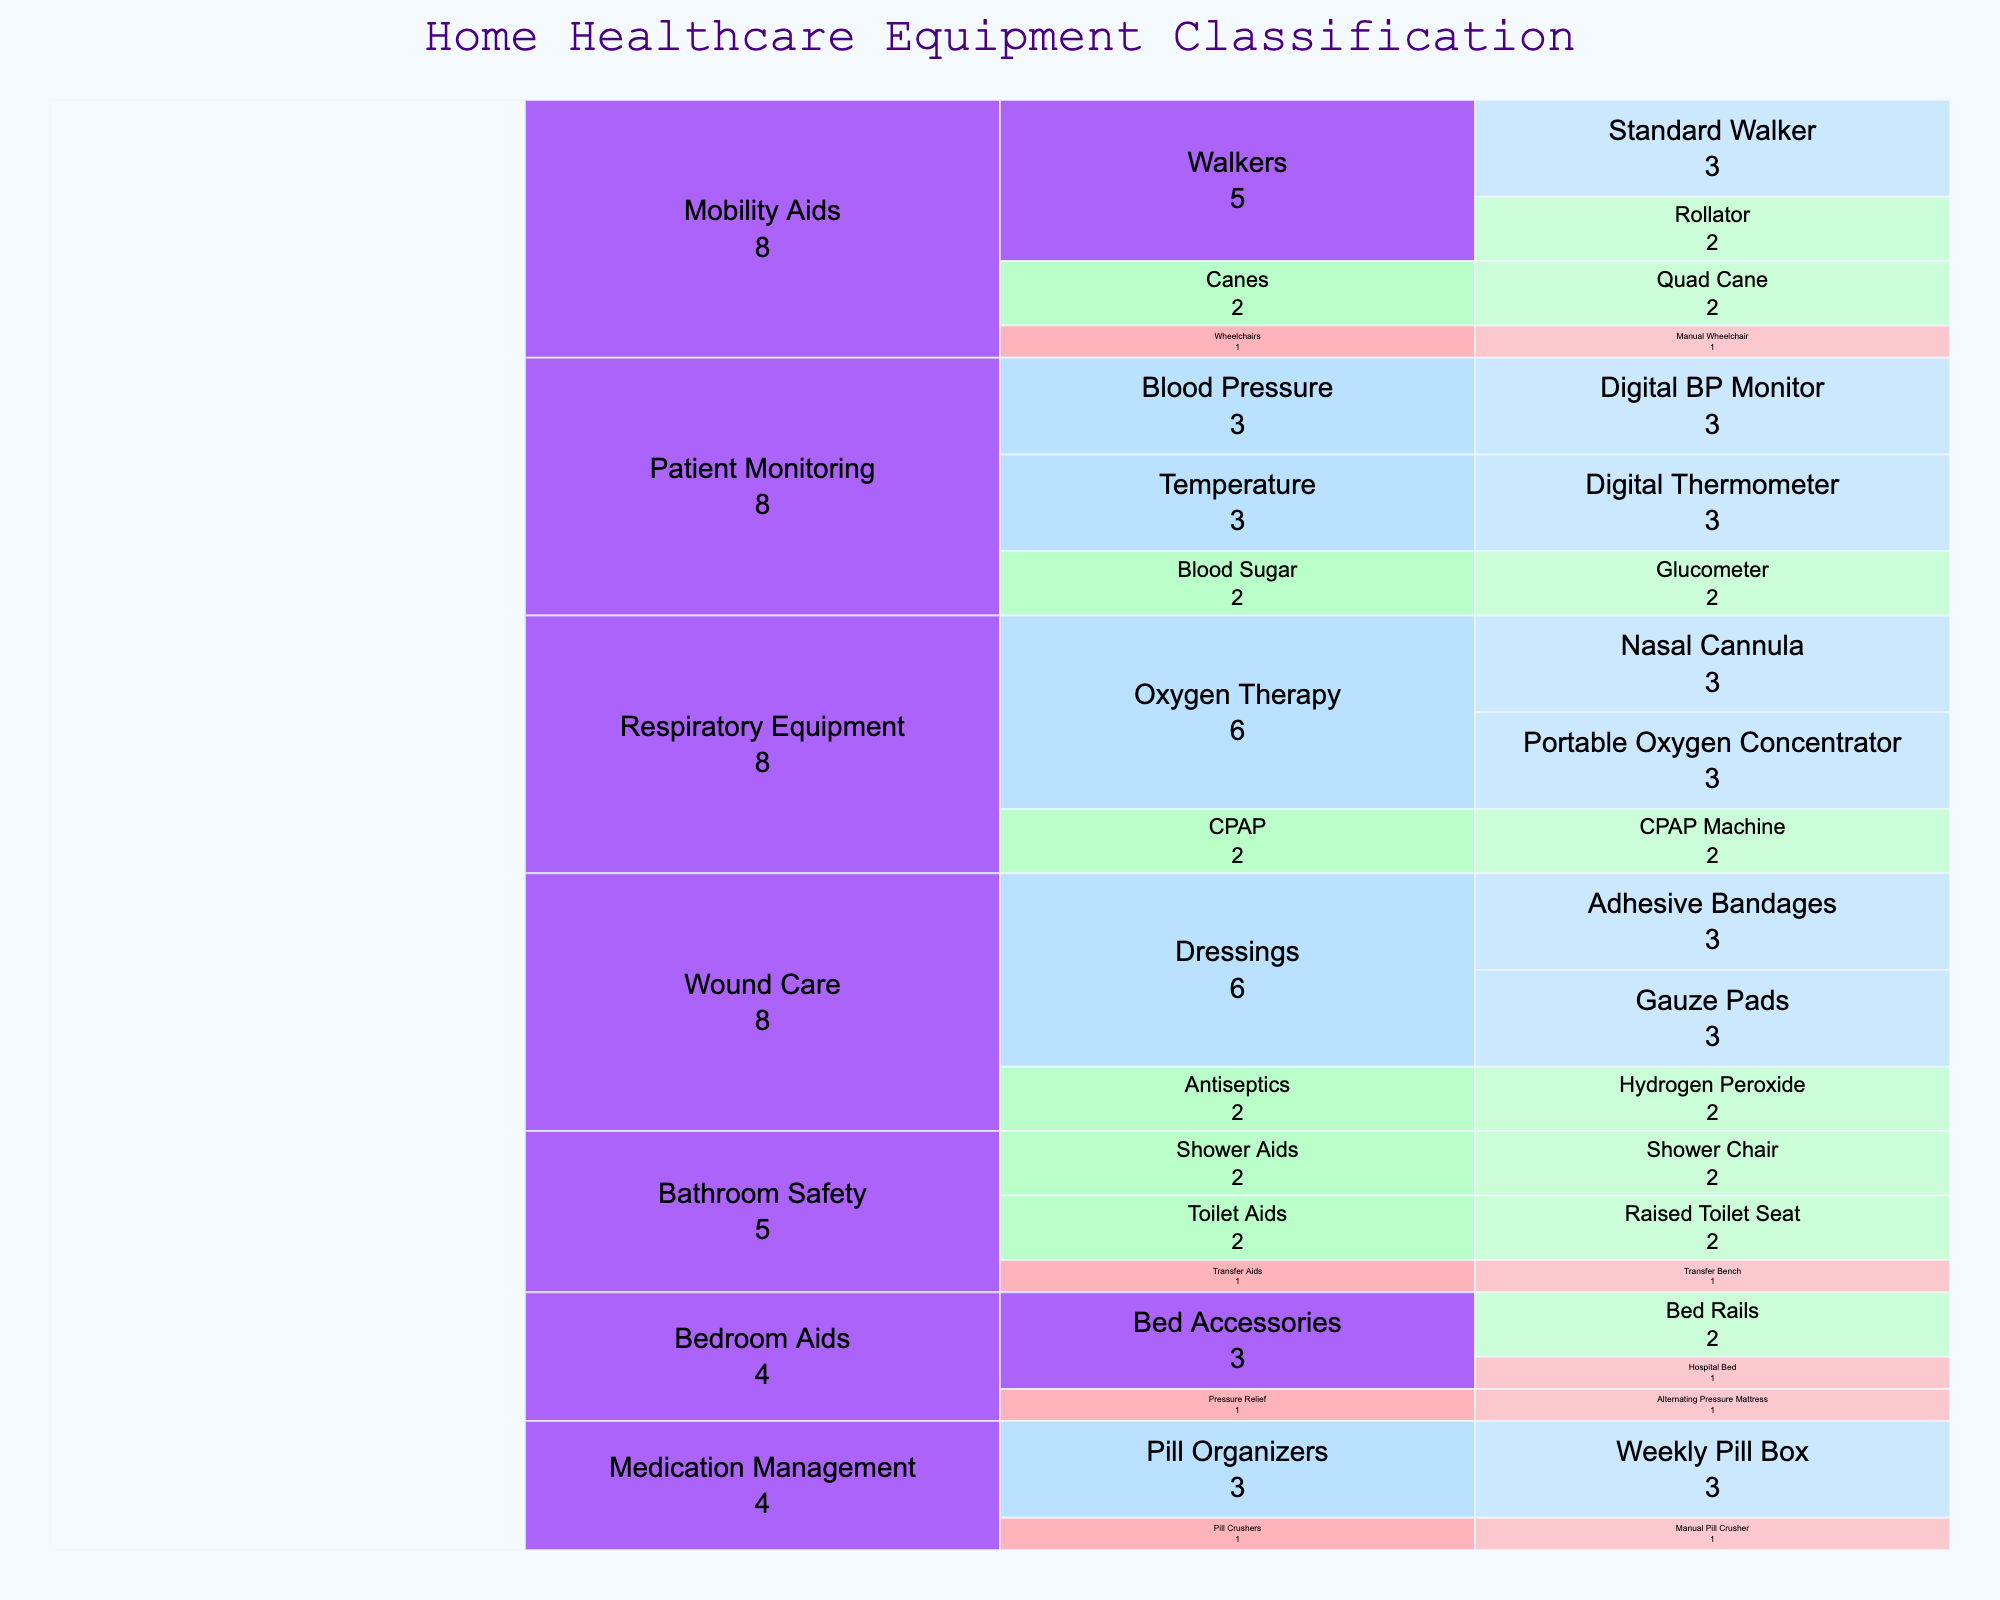What's the title of the figure? The title is located at the top of the Icicle chart and provides a summary of what the figure represents. In this case, it is 'Home Healthcare Equipment Classification'.
Answer: Home Healthcare Equipment Classification What is the most frequently used item under Respiratory Equipment? To find the most frequently used item under Respiratory Equipment, look for the items with the highest frequency ('High'). Both Portable Oxygen Concentrator and Nasal Cannula have a 'High' frequency.
Answer: Portable Oxygen Concentrator and Nasal Cannula How many categories of equipment are represented in the chart? The categories are the top-level branches in the Icicle chart. Count how many separate categories there are. The categories are: Mobility Aids, Respiratory Equipment, Wound Care, Medication Management, Bathroom Safety, Patient Monitoring, and Bedroom Aids.
Answer: 7 Which category has the item with the lowest frequency of use? Look for the items marked with 'Low' frequency and identify their parent category. Both 'Manual Wheelchair' in Mobility Aids and 'Hospital Bed' in Bedroom Aids among others have 'Low' frequency. Check the overall lowest frequencies. All 'Low' frequency items belong to either Mobility Aids, Medication Management, Bathroom Safety, or Bedroom Aids.
Answer: Mobility Aids, Medication Management, Bathroom Safety, and Bedroom Aids How many subcategories are there under Wound Care? Under the Wound Care category, count the subcategories. There are Dressings and Antiseptics.
Answer: 2 Which item under Patient Monitoring is used the most frequently? Under the Patient Monitoring category, look for items with the highest frequency. Digital BP Monitor and Digital Thermometer both have 'High' frequency.
Answer: Digital BP Monitor and Digital Thermometer Which items are under the Bathroom Safety category and have a 'Medium' frequency? Examine the Bathroom Safety category and list the items marked with a 'Medium' frequency. Raised Toilet Seat and Shower Chair have a 'Medium' frequency.
Answer: Raised Toilet Seat and Shower Chair 